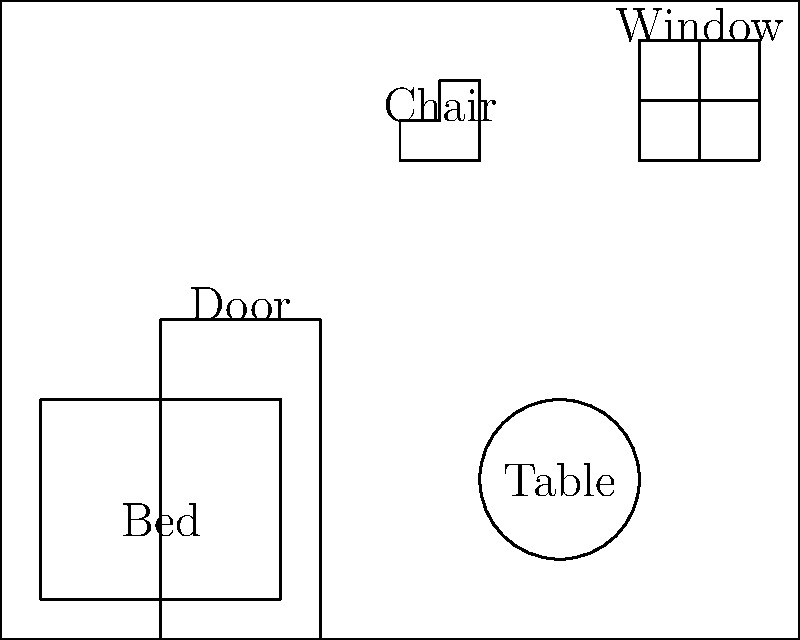In the hospital room shown, how many different shapes can you identify? Name these shapes. Let's go through the room step-by-step to identify the different shapes:

1. Room outline: The room itself is a rectangle.

2. Window: The window is composed of a rectangle, divided into four smaller rectangles.

3. Door: The door is represented by a rectangle.

4. Bed: The bed is shown as a rectangle.

5. Table: The table is represented by a circle.

6. Chair: The chair is an irregular polygon, specifically a hexagon.

In total, we can identify three different shapes:
- Rectangle (found in the room outline, window, door, and bed)
- Circle (the table)
- Hexagon (the chair)
Answer: 3 shapes: rectangle, circle, and hexagon 